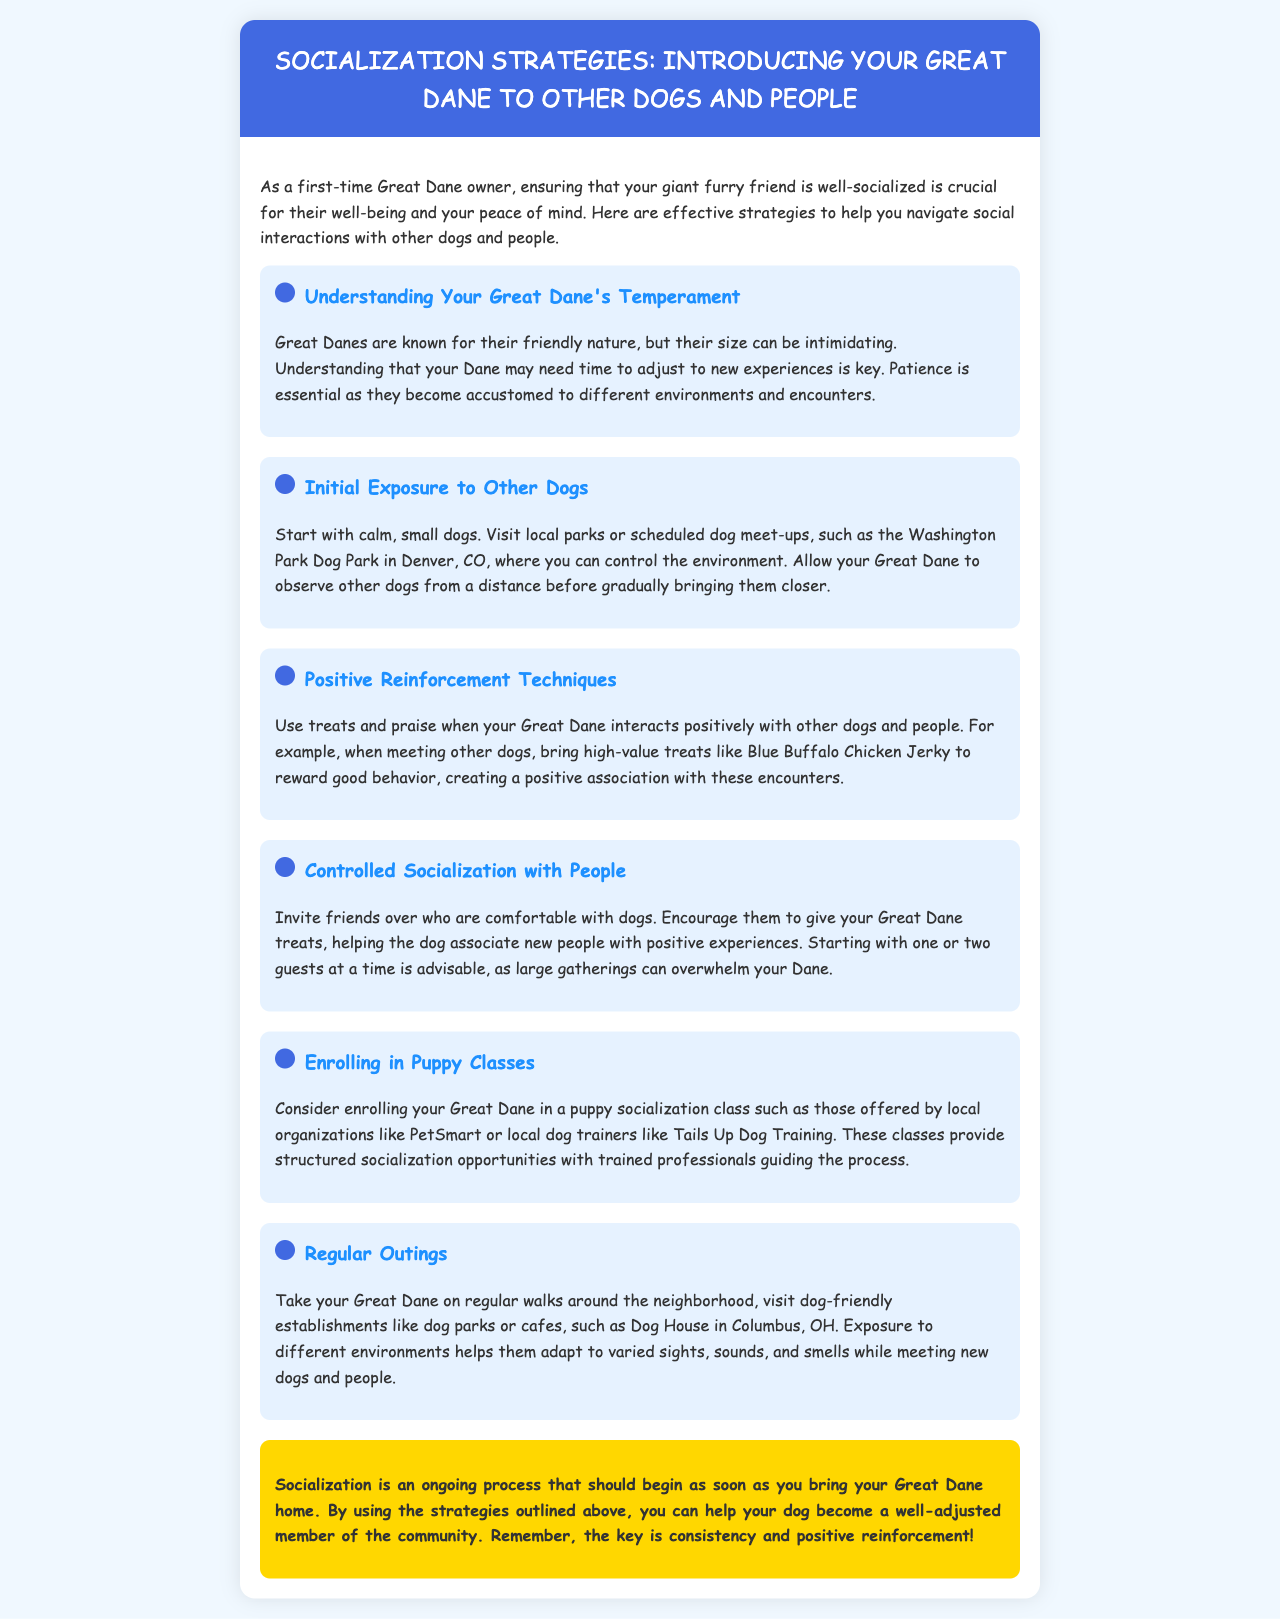What is the title of the newsletter? The title of the newsletter is prominently displayed in the header of the document.
Answer: Socialization Strategies: Introducing Your Great Dane to Other Dogs and People What should you start with for initial exposure to other dogs? The document suggests beginning with smaller, calm dogs for initial encounters.
Answer: Calm, small dogs Which dog park is mentioned in the document? The newsletter provides a specific location for dog meet-ups to help with socialization.
Answer: Washington Park Dog Park What should you use for positive reinforcement? The document specifically mentions an example of a treat that can be used for rewarding good behavior during interactions.
Answer: Blue Buffalo Chicken Jerky What are the benefits of enrolling in puppy classes? The document mentions structured socialization opportunities with guidance from professionals as a key reason to enroll.
Answer: Structured socialization opportunities How should you introduce your Great Dane to new people? The newsletter provides a strategy for inviting friends over who are comfortable with dogs, emphasizing a gradual introduction.
Answer: Invite friends over What is the key to socialization according to the conclusion? The conclusion emphasizes the importance of a consistent approach to socialization for the Great Dane’s adjustment.
Answer: Consistency and positive reinforcement 